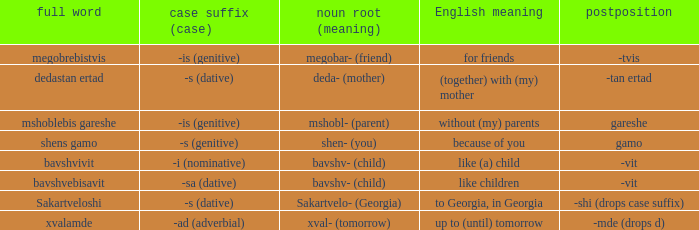What is English Meaning, when Full Word is "Shens Gamo"? Because of you. 